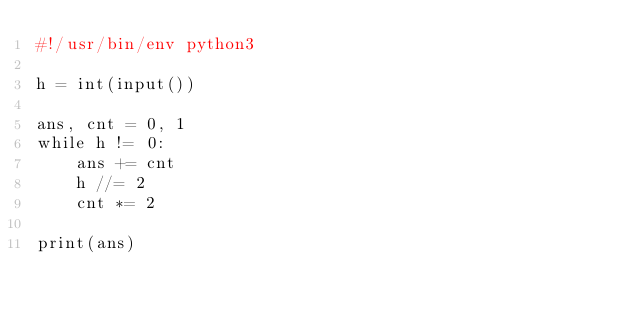<code> <loc_0><loc_0><loc_500><loc_500><_Python_>#!/usr/bin/env python3

h = int(input())

ans, cnt = 0, 1 
while h != 0:
    ans += cnt
    h //= 2
    cnt *= 2

print(ans)

</code> 